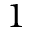Convert formula to latex. <formula><loc_0><loc_0><loc_500><loc_500>1</formula> 